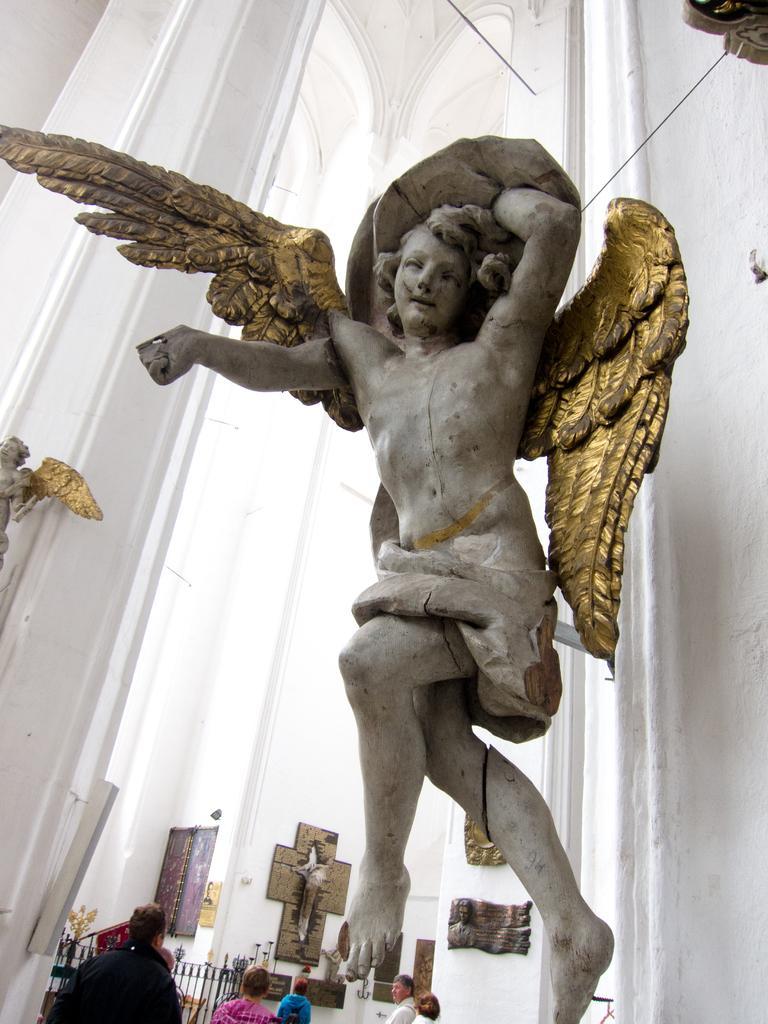Could you give a brief overview of what you see in this image? In this picture we can see the statues of an angel. There are a few objects on the wall. We can see a few people in the background. 